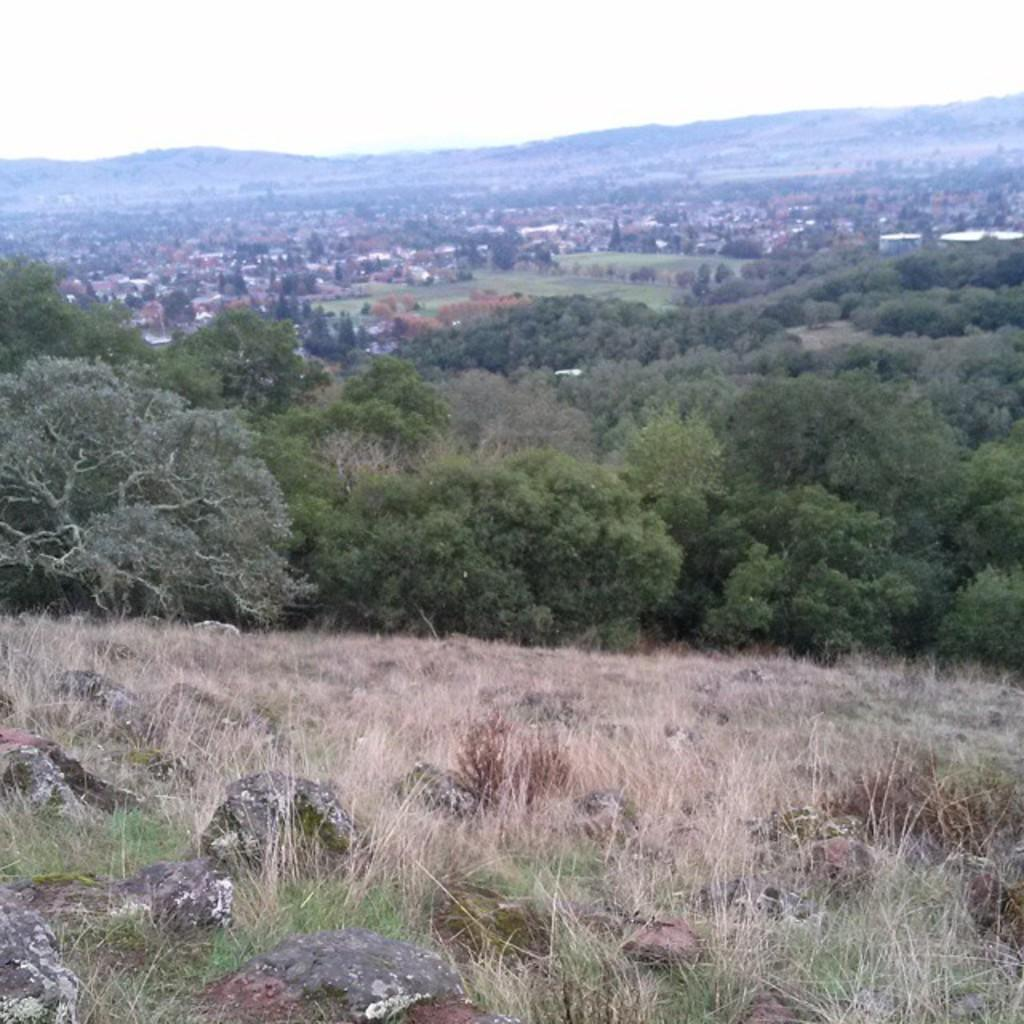What type of vegetation is present in the image? There is grass in the image. What other natural elements can be seen in the image? There are trees in the image. What is visible in the background of the image? The sky is visible in the background of the image. What type of pain is being expressed by the government in the image? There is no government or any indication of pain in the image; it features grass, trees, and the sky. 